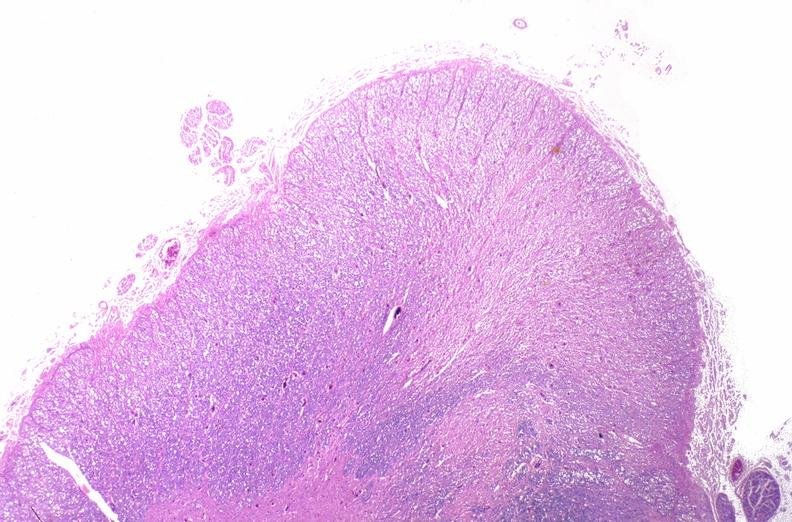does this image show spinal cord injury due to vertebral column trauma, demyelination?
Answer the question using a single word or phrase. Yes 